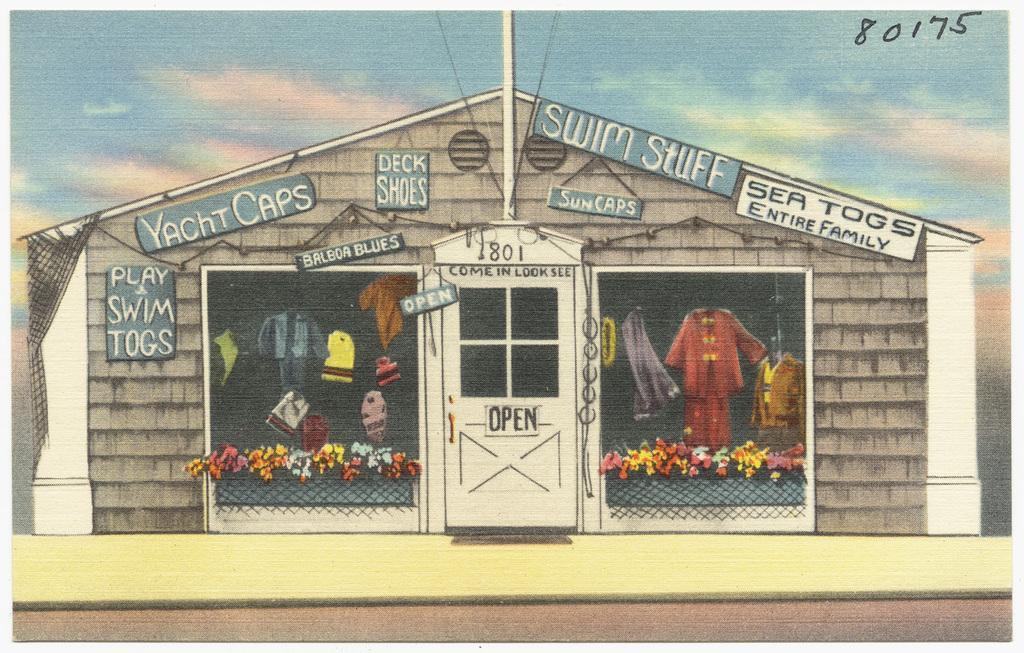How would you summarize this image in a sentence or two? In this image there is a depiction of a house with name boards, posters on it. There is a closed door and there are some text and numbers on the door. In the background of the image there are clouds in the sky. 